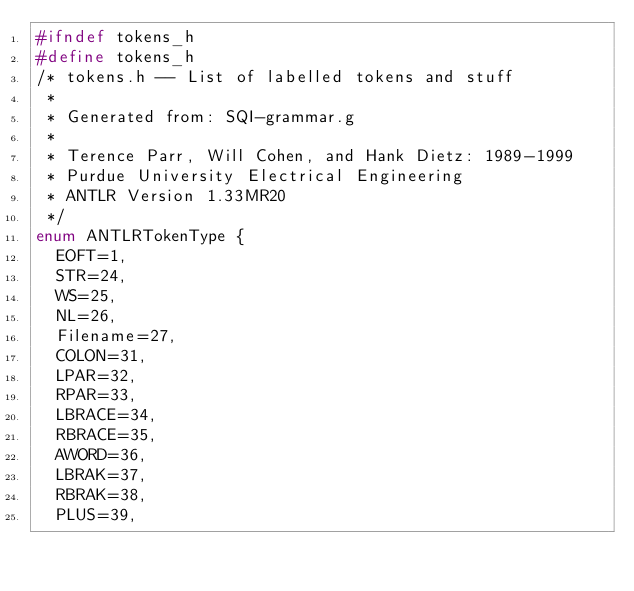<code> <loc_0><loc_0><loc_500><loc_500><_C_>#ifndef tokens_h
#define tokens_h
/* tokens.h -- List of labelled tokens and stuff
 *
 * Generated from: SQI-grammar.g
 *
 * Terence Parr, Will Cohen, and Hank Dietz: 1989-1999
 * Purdue University Electrical Engineering
 * ANTLR Version 1.33MR20
 */
enum ANTLRTokenType {
	EOFT=1,
	STR=24,
	WS=25,
	NL=26,
	Filename=27,
	COLON=31,
	LPAR=32,
	RPAR=33,
	LBRACE=34,
	RBRACE=35,
	AWORD=36,
	LBRAK=37,
	RBRAK=38,
	PLUS=39,</code> 